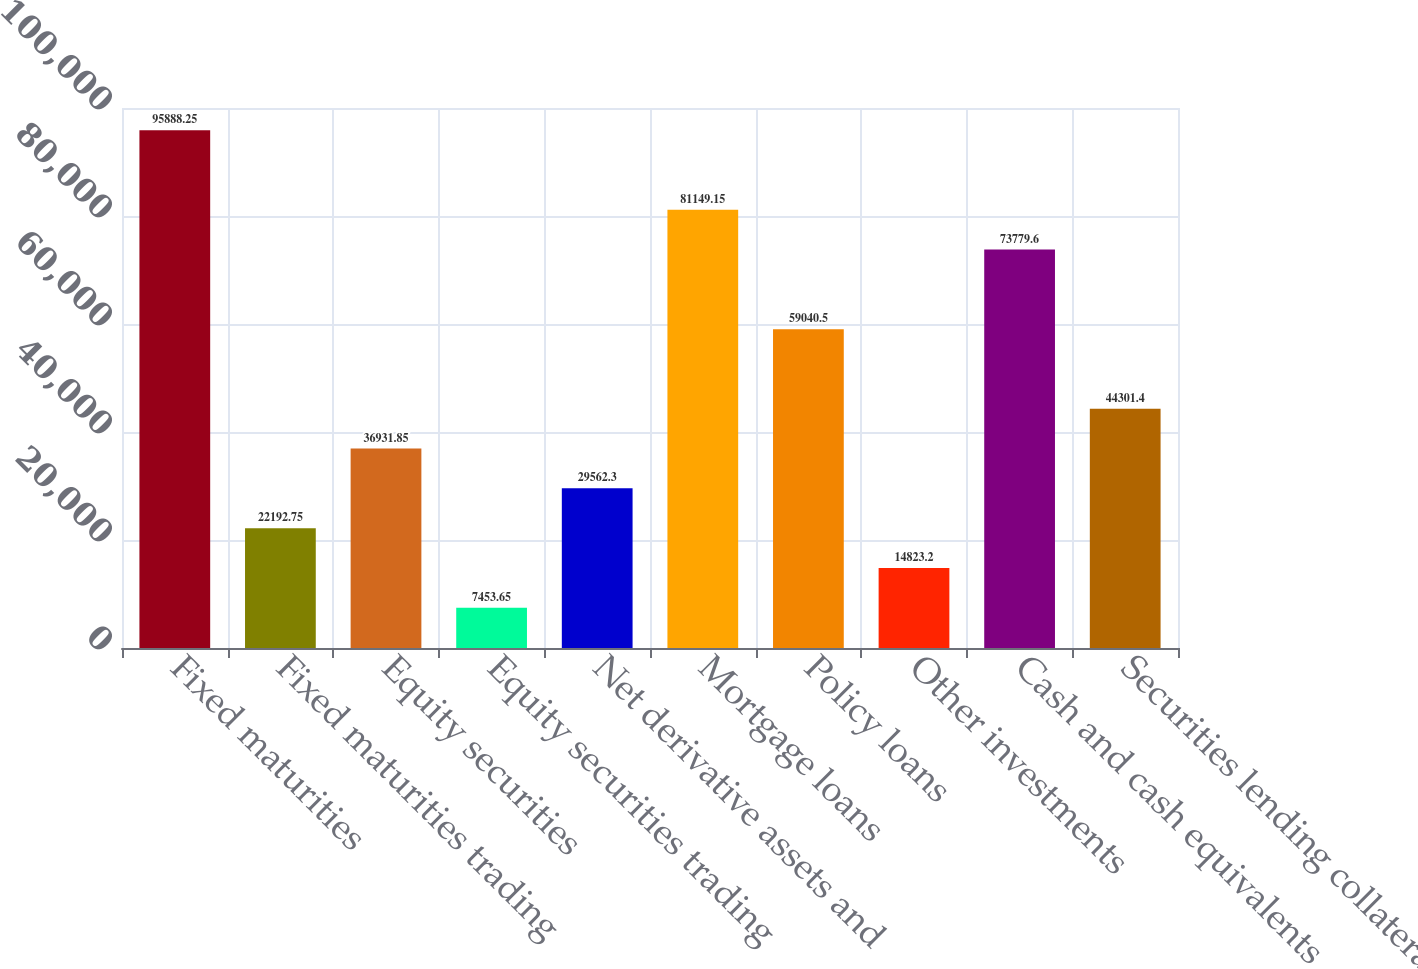Convert chart. <chart><loc_0><loc_0><loc_500><loc_500><bar_chart><fcel>Fixed maturities<fcel>Fixed maturities trading<fcel>Equity securities<fcel>Equity securities trading<fcel>Net derivative assets and<fcel>Mortgage loans<fcel>Policy loans<fcel>Other investments<fcel>Cash and cash equivalents<fcel>Securities lending collateral<nl><fcel>95888.2<fcel>22192.8<fcel>36931.8<fcel>7453.65<fcel>29562.3<fcel>81149.1<fcel>59040.5<fcel>14823.2<fcel>73779.6<fcel>44301.4<nl></chart> 